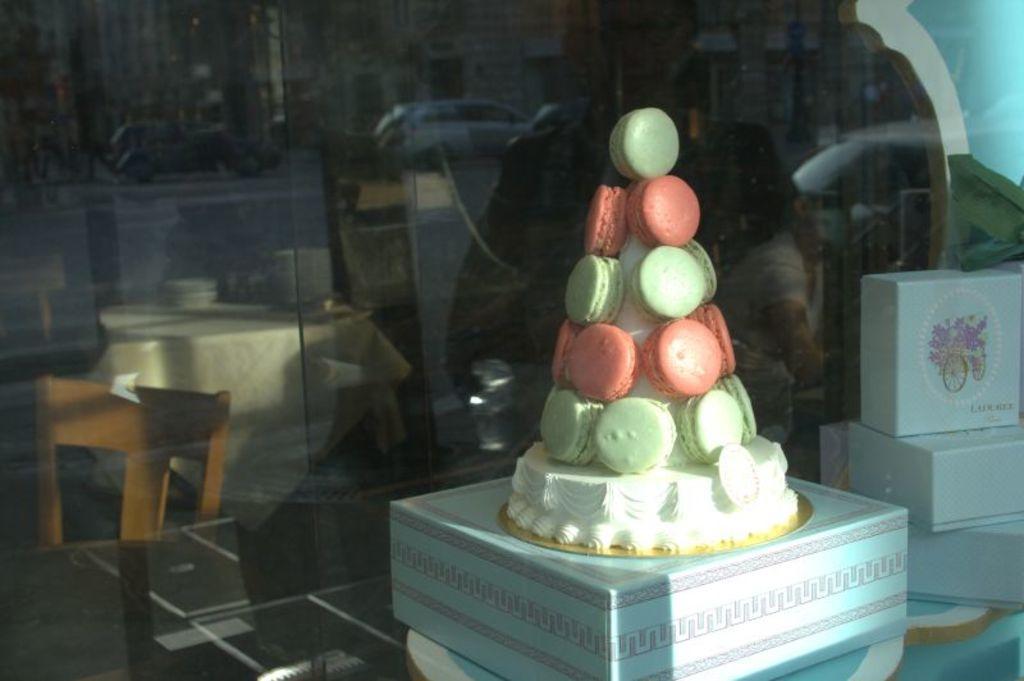Please provide a concise description of this image. There is a cake on a box. Beside it there are few more boxes on a table. On the background there is a glass wall. 